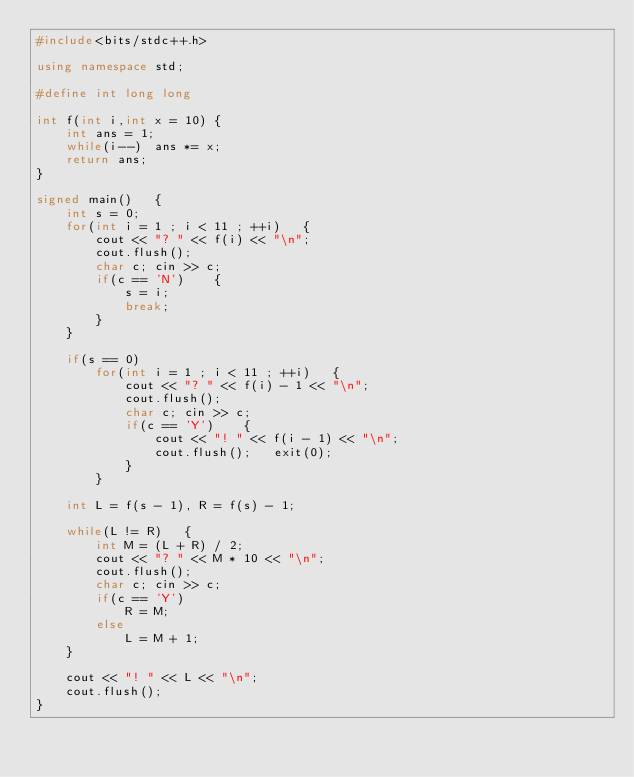Convert code to text. <code><loc_0><loc_0><loc_500><loc_500><_C++_>#include<bits/stdc++.h>

using namespace std;

#define int long long

int f(int i,int x = 10) {
	int ans = 1;
	while(i--)  ans *= x;
	return ans;
}

signed main()   {
	int s = 0;
	for(int i = 1 ; i < 11 ; ++i)   {
		cout << "? " << f(i) << "\n";
		cout.flush();
		char c; cin >> c;
		if(c == 'N')    {
			s = i;
			break;
		}
	}
	
	if(s == 0)
		for(int i = 1 ; i < 11 ; ++i)   {
			cout << "? " << f(i) - 1 << "\n";
			cout.flush();
			char c; cin >> c;
			if(c == 'Y')    {
				cout << "! " << f(i - 1) << "\n";
				cout.flush();   exit(0);
			}
		}
	
	int L = f(s - 1), R = f(s) - 1;
	
	while(L != R)   {
		int M = (L + R) / 2;
		cout << "? " << M * 10 << "\n";
		cout.flush();
		char c; cin >> c;
		if(c == 'Y')
			R = M;
		else
			L = M + 1;
	}
	
	cout << "! " << L << "\n";
	cout.flush();
}</code> 